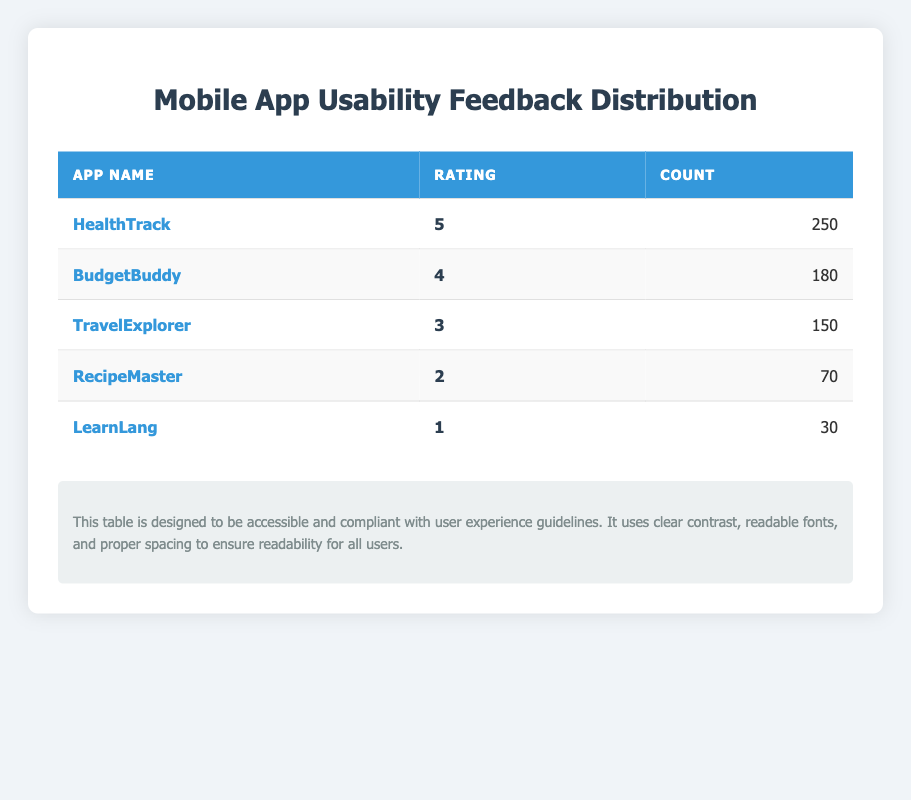What is the highest rating given to an app? The highest rating in the table is clearly indicated next to "HealthTrack," which has a rating of 5.
Answer: 5 How many users rated "BudgetBuddy" with a score of 4? The table indicates that "BudgetBuddy" received a score of 4 from 180 users.
Answer: 180 Which app has the least user feedback count? The app "LearnLang" has the least user feedback count, with only 30 ratings as shown in the table.
Answer: LearnLang What is the total count of all users who provided feedback? To find the total count of all users, we sum the counts: 250 + 180 + 150 + 70 + 30 = 680.
Answer: 680 Is it true that more users rated "TravelExplorer" than "RecipeMaster"? Yes, looking at the counts, "TravelExplorer" has 150 ratings and "RecipeMaster" has 70 ratings, which means "TravelExplorer" was rated by more users.
Answer: Yes What is the average rating across all apps? We calculate the average rating by multiplying each rating by its count, summing them up, and dividing by the total count: (5*250 + 4*180 + 3*150 + 2*70 + 1*30) = 1910, and total count is 680, so average rating = 1910 / 680 ≈ 2.81.
Answer: 2.81 Which app received a rating of 2, and how many users rated it? "RecipeMaster" received a rating of 2, and the table states that 70 users provided this rating.
Answer: RecipeMaster, 70 What percentage of users gave the highest rating of 5? To find the percentage, we divide the number of users who rated 5 (250) by the total count (680) and multiply by 100: (250/680)*100 ≈ 36.76%.
Answer: 36.76% How many more users rated the top app compared to the app with the lowest rating? "HealthTrack" has 250 ratings and "LearnLang" has 30 ratings. The difference is 250 - 30 = 220.
Answer: 220 